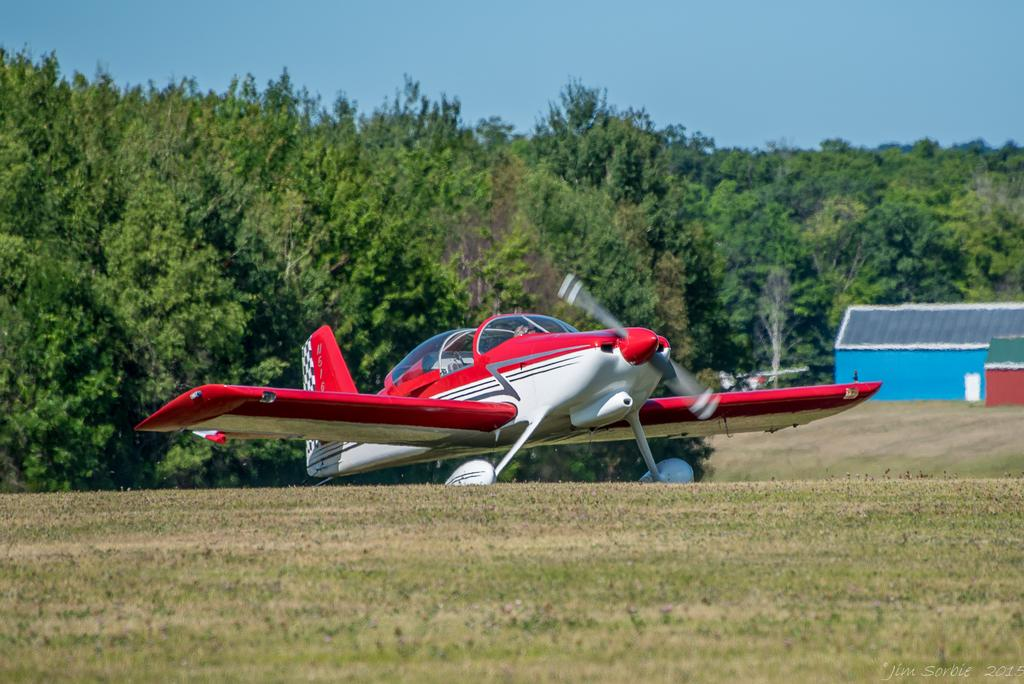What is the main subject of the image? The main subject of the image is a plane. Where is the plane located in the image? The plane is on the ground. What can be seen in the background of the image? There are trees, houses, and the sky visible in the background of the image. What type of agreement is being signed by the plane in the image? There is no agreement being signed in the image, as it features a plane on the ground with trees, houses, and the sky in the background. 